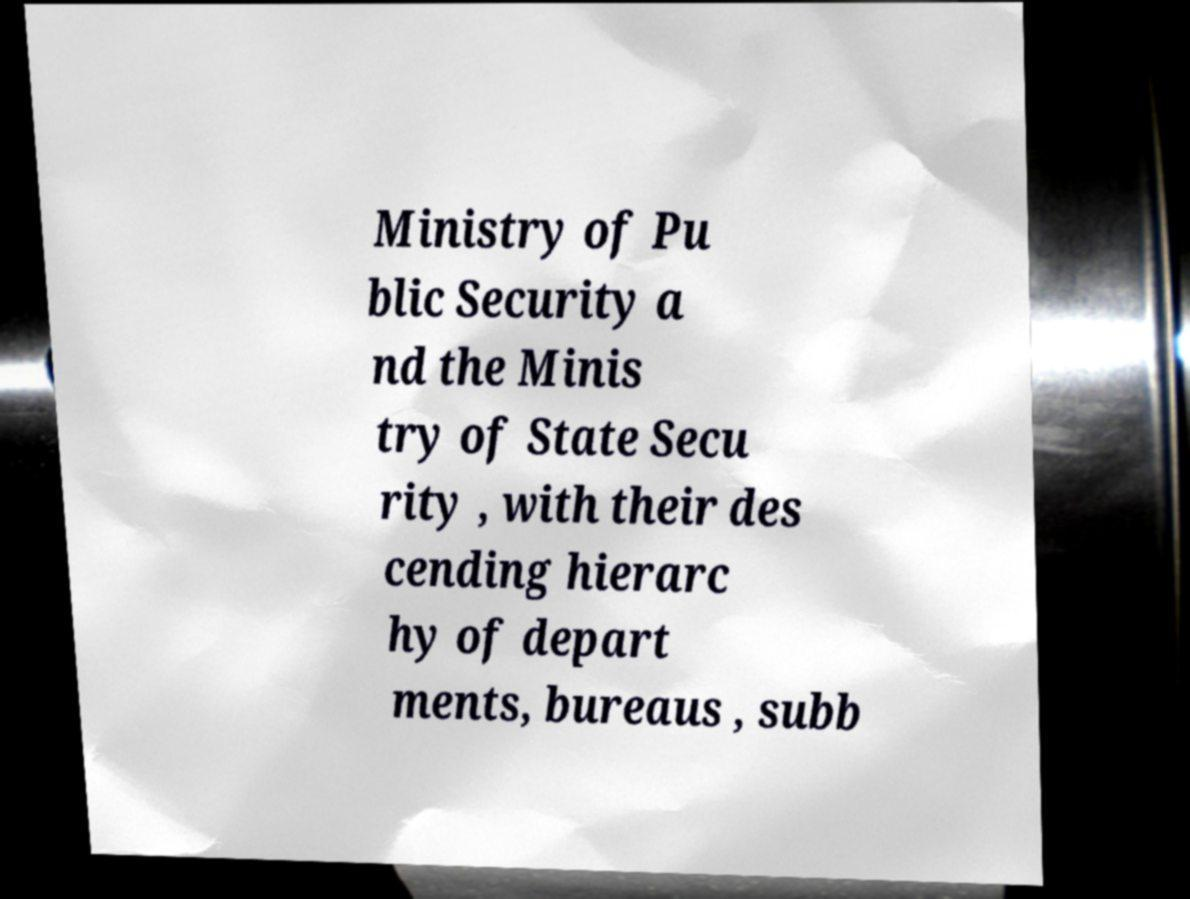Please read and relay the text visible in this image. What does it say? Ministry of Pu blic Security a nd the Minis try of State Secu rity , with their des cending hierarc hy of depart ments, bureaus , subb 